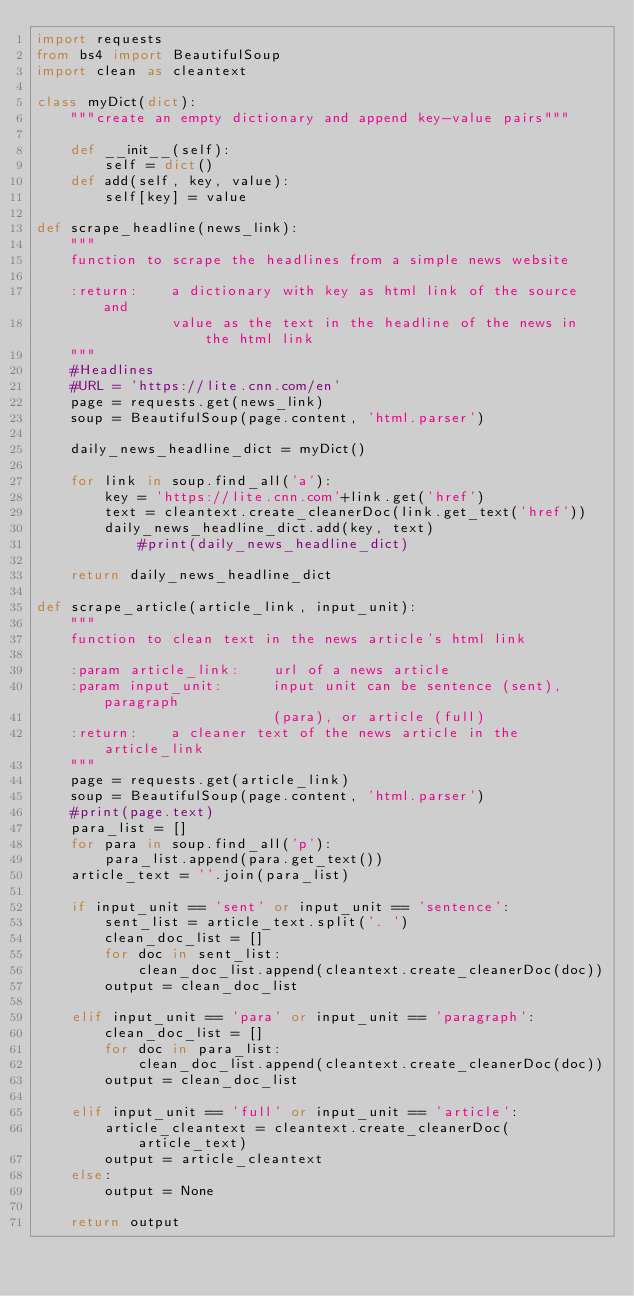<code> <loc_0><loc_0><loc_500><loc_500><_Python_>import requests
from bs4 import BeautifulSoup
import clean as cleantext

class myDict(dict):
    """create an empty dictionary and append key-value pairs"""

    def __init__(self):
        self = dict()
    def add(self, key, value):
        self[key] = value

def scrape_headline(news_link):
    """
    function to scrape the headlines from a simple news website

    :return:    a dictionary with key as html link of the source and
                value as the text in the headline of the news in the html link
    """
    #Headlines
    #URL = 'https://lite.cnn.com/en'
    page = requests.get(news_link)
    soup = BeautifulSoup(page.content, 'html.parser')

    daily_news_headline_dict = myDict()

    for link in soup.find_all('a'):
        key = 'https://lite.cnn.com'+link.get('href')
        text = cleantext.create_cleanerDoc(link.get_text('href'))
        daily_news_headline_dict.add(key, text)
            #print(daily_news_headline_dict)

    return daily_news_headline_dict

def scrape_article(article_link, input_unit):
    """
    function to clean text in the news article's html link

    :param article_link:    url of a news article
    :param input_unit:      input unit can be sentence (sent), paragraph
                            (para), or article (full)
    :return:    a cleaner text of the news article in the article_link
    """
    page = requests.get(article_link)
    soup = BeautifulSoup(page.content, 'html.parser')
    #print(page.text)
    para_list = []
    for para in soup.find_all('p'):
        para_list.append(para.get_text())
    article_text = ''.join(para_list)

    if input_unit == 'sent' or input_unit == 'sentence':
        sent_list = article_text.split('. ')
        clean_doc_list = []
        for doc in sent_list:
            clean_doc_list.append(cleantext.create_cleanerDoc(doc))
        output = clean_doc_list

    elif input_unit == 'para' or input_unit == 'paragraph':
        clean_doc_list = []
        for doc in para_list:
            clean_doc_list.append(cleantext.create_cleanerDoc(doc))
        output = clean_doc_list

    elif input_unit == 'full' or input_unit == 'article':
        article_cleantext = cleantext.create_cleanerDoc(article_text)
        output = article_cleantext
    else:
        output = None

    return output
</code> 